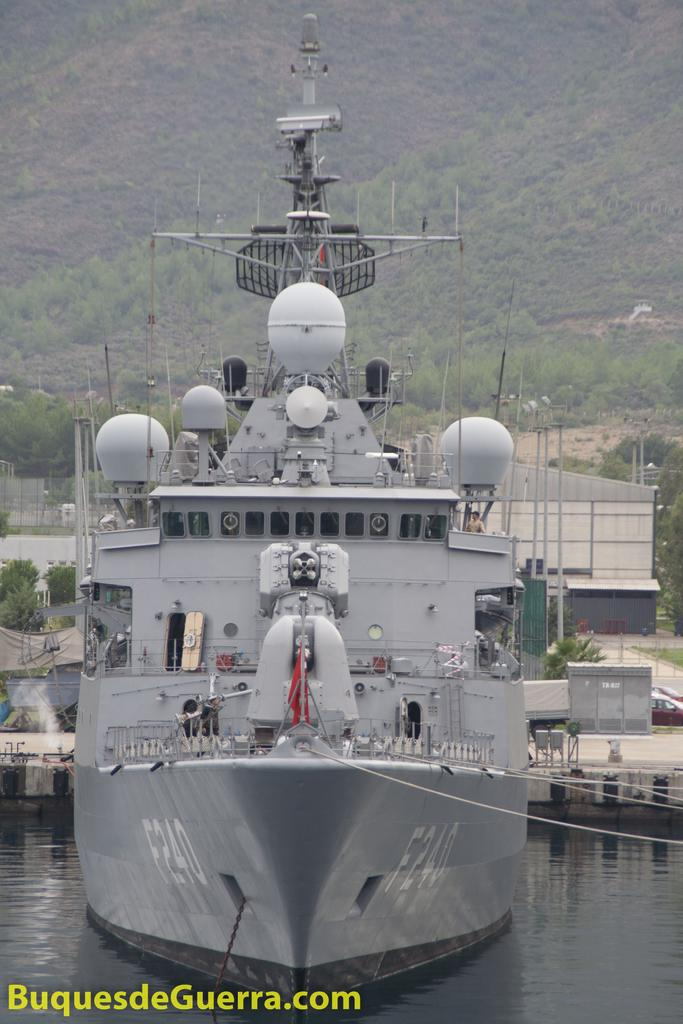What type of vehicle is in the water in the image? There is a war ship in the water in the image. What other types of vehicles can be seen in the image? There are no other vehicles visible in the image. What structures are present in the image? There are buildings in the image. What type of natural scenery is visible in the background of the image? There are trees in the background of the image. Is there any text or marking on the image itself? Yes, there is a watermark on the image. What type of marble is used to construct the buildings in the image? There is no mention of marble being used to construct the buildings in the image; the fact only states that there are buildings present. 